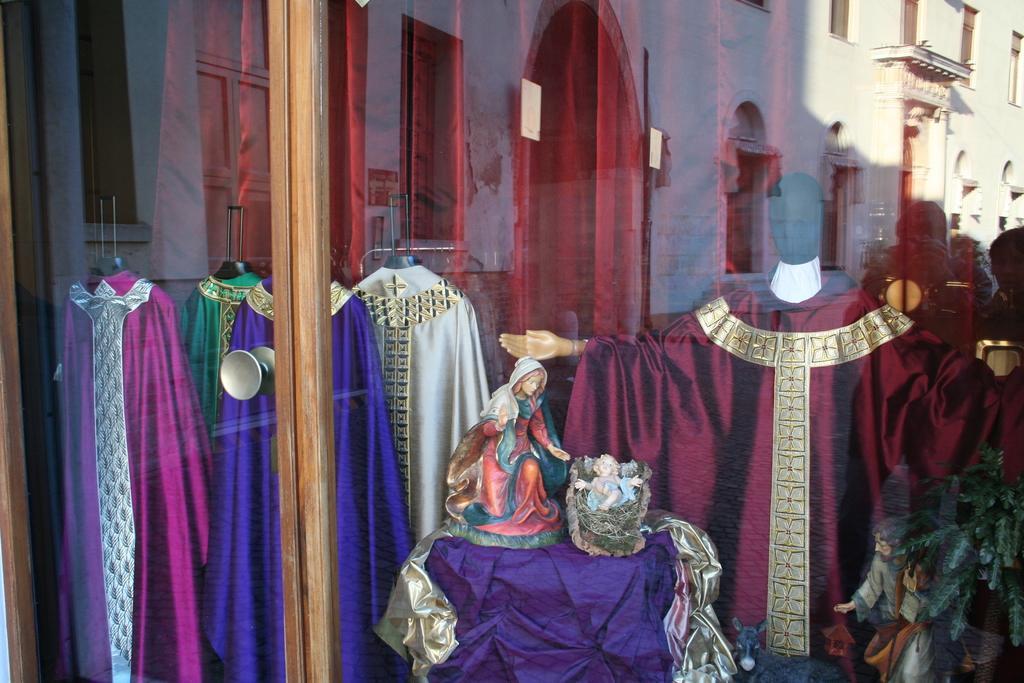Please provide a concise description of this image. This image is taken outdoors. In this image there is a store with a glass door. Through the door we can see there are a few costumes on the mannequins and there are a few toys. At the top right of the image there is a shadow of a building. 